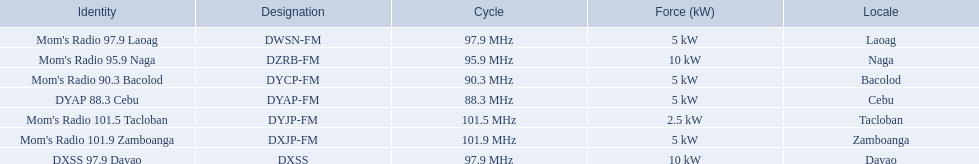Which stations broadcast in dyap-fm? Mom's Radio 97.9 Laoag, Mom's Radio 95.9 Naga, Mom's Radio 90.3 Bacolod, DYAP 88.3 Cebu, Mom's Radio 101.5 Tacloban, Mom's Radio 101.9 Zamboanga, DXSS 97.9 Davao. Of those stations which broadcast in dyap-fm, which stations broadcast with 5kw of power or under? Mom's Radio 97.9 Laoag, Mom's Radio 90.3 Bacolod, DYAP 88.3 Cebu, Mom's Radio 101.5 Tacloban, Mom's Radio 101.9 Zamboanga. Of those stations that broadcast with 5kw of power or under, which broadcasts with the least power? Mom's Radio 101.5 Tacloban. 